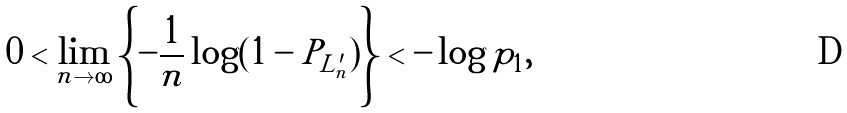Convert formula to latex. <formula><loc_0><loc_0><loc_500><loc_500>0 < \lim _ { n \to \infty } \left \{ - \frac { 1 } { n } \log ( 1 - P _ { L ^ { \prime } _ { n } } ) \right \} < - \log p _ { 1 } ,</formula> 